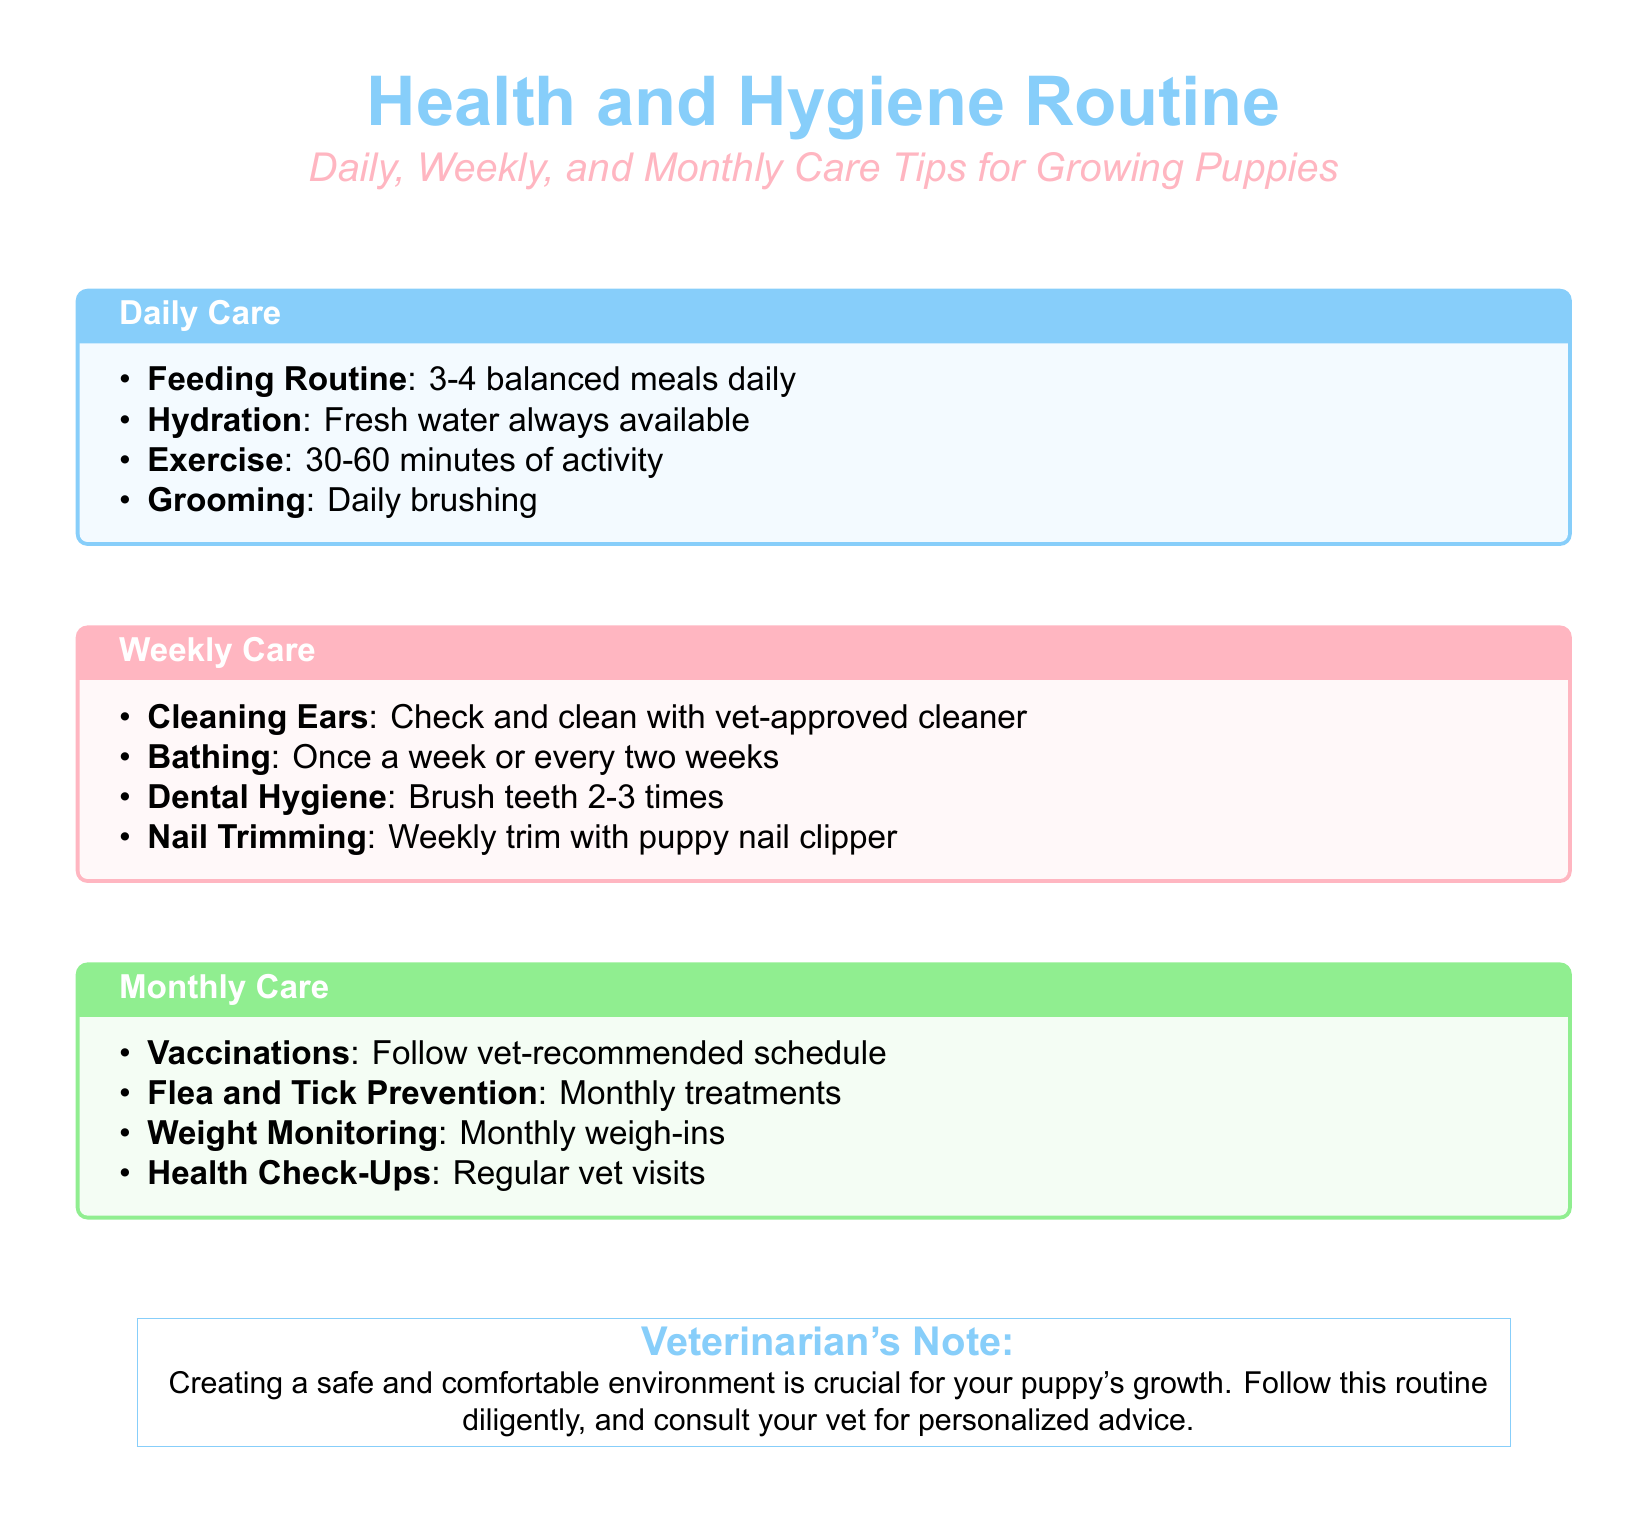what is the title of the document? The title appears prominently at the top, stated as "Health and Hygiene Routine."
Answer: Health and Hygiene Routine how many balanced meals should a puppy have daily? The daily care section specifies feeding a puppy 3-4 meals.
Answer: 3-4 what is the recommended bathing frequency for puppies? The weekly care section mentions bathing once a week or every two weeks.
Answer: Once a week or every two weeks how often should teeth be brushed according to the document? The weekly care section states that teeth should be brushed 2-3 times.
Answer: 2-3 times what month should flea and tick prevention be administered? The monthly care section states that flea and tick prevention is needed monthly.
Answer: Monthly what type of cleaning is advised for the ears? The weekly care section specifies cleaning ears with a vet-approved cleaner.
Answer: Vet-approved cleaner how often should a puppy visit the vet for health check-ups? According to the monthly care tips, regular vet visits are necessary for health check-ups.
Answer: Regularly what color is used for the title of the document? The color section of the code specifies that the title color is puppyblue.
Answer: Puppyblue 